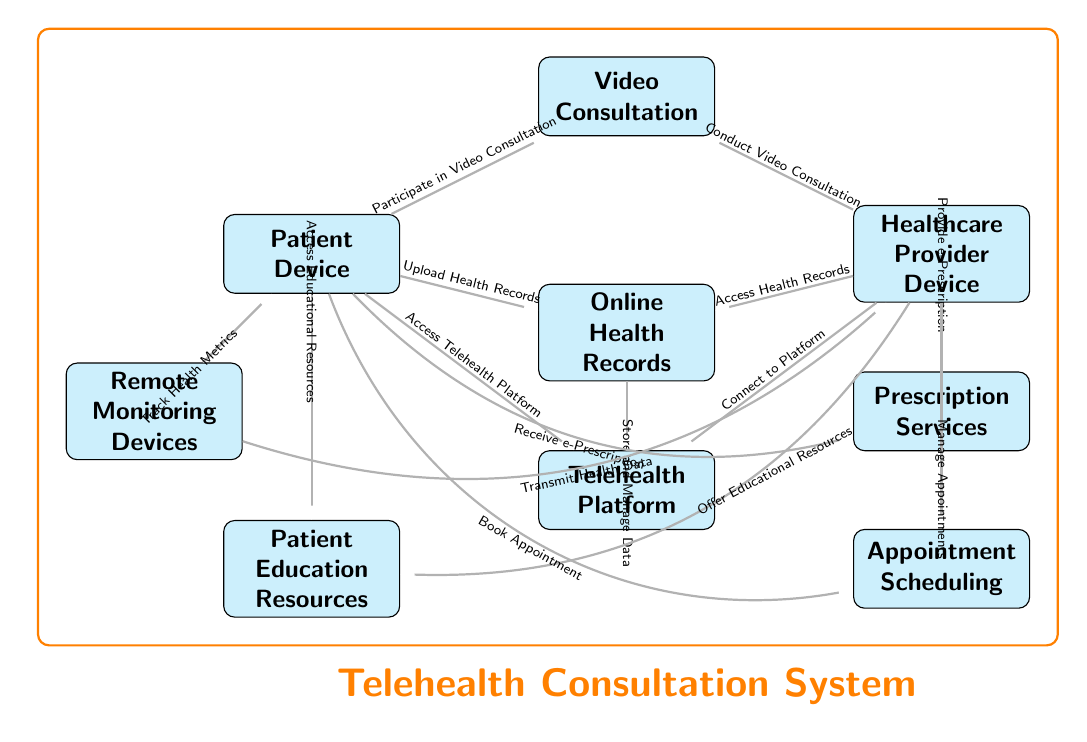What are the nodes present in the diagram? The nodes present in the diagram are: Patient Device, Telehealth Platform, Healthcare Provider Device, Video Consultation, Online Health Records, Prescription Services, Remote Monitoring Devices, Patient Education Resources, and Appointment Scheduling.
Answer: Patient Device, Telehealth Platform, Healthcare Provider Device, Video Consultation, Online Health Records, Prescription Services, Remote Monitoring Devices, Patient Education Resources, Appointment Scheduling How many edges are there in the diagram? Counting the arrows connecting the nodes, there are a total of 12 edges in the diagram.
Answer: 12 Which node connects to the Telehealth Platform from the Patient Device? The Patient Device connects to the Telehealth Platform with the relation "Access Telehealth Platform." This connection indicates that the patient starts the process by accessing the platform through their device.
Answer: Access Telehealth Platform What is the role of the Healthcare Provider Device in the video consultation? The Healthcare Provider Device is involved in the video consultation process by "Conducting Video Consultation." This shows that healthcare providers use their devices to carry out the consultation.
Answer: Conduct Video Consultation What can the patient receive from the Prescription Services? The patient can receive an “e-Prescription” from the Prescription Services after a consultation, indicating that prescriptions are provided electronically.
Answer: e-Prescription How do Remote Monitoring Devices interact with the Patient Device? Remote Monitoring Devices "Track Health Metrics" and "Transmit Health Data" to the Patient Device, enabling the patient to monitor their health and possibly share that information with their healthcare provider.
Answer: Track Health Metrics, Transmit Health Data Which two nodes are directly linked to Online Health Records? Online Health Records are directly linked to both the Patient Device for "Upload Health Records" and the Healthcare Provider Device for "Access Health Records." This indicates an exchange of health information between patients and providers.
Answer: Patient Device, Healthcare Provider Device What is the purpose of the node labeled Patient Education Resources? The purpose of the Patient Education Resources is to provide health information that supports the patient, allowing them to access educational resources about their health conditions or treatments during their consultation experience.
Answer: Offer Educational Resources How does the patient schedule an appointment in the telehealth system? The patient can schedule an appointment by "Booking Appointment" which indicates that they initiate the scheduling process from their device and it relates to the Appointment Scheduling node.
Answer: Book Appointment What is the overall title of this diagram indicating the system it represents? The overall title indicating the system this diagram represents is "Telehealth Consultation System," which encompasses the entire workflow and the components involved in telehealth.
Answer: Telehealth Consultation System 